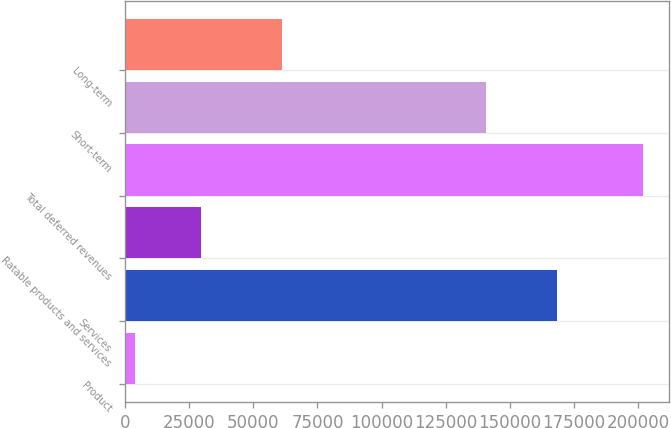Convert chart. <chart><loc_0><loc_0><loc_500><loc_500><bar_chart><fcel>Product<fcel>Services<fcel>Ratable products and services<fcel>Total deferred revenues<fcel>Short-term<fcel>Long-term<nl><fcel>4141<fcel>168314<fcel>29475<fcel>201930<fcel>140537<fcel>61393<nl></chart> 